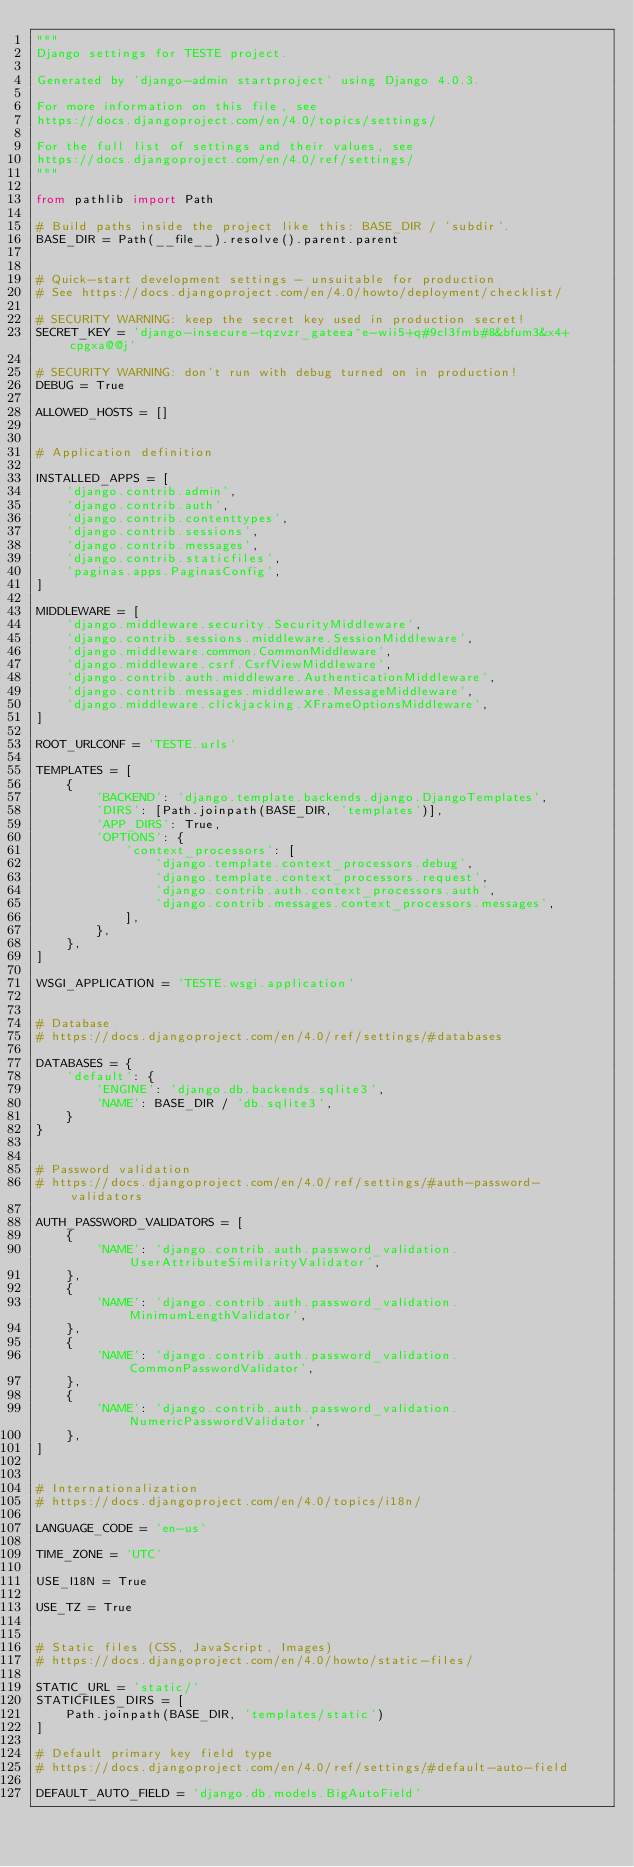Convert code to text. <code><loc_0><loc_0><loc_500><loc_500><_Python_>"""
Django settings for TESTE project.

Generated by 'django-admin startproject' using Django 4.0.3.

For more information on this file, see
https://docs.djangoproject.com/en/4.0/topics/settings/

For the full list of settings and their values, see
https://docs.djangoproject.com/en/4.0/ref/settings/
"""

from pathlib import Path

# Build paths inside the project like this: BASE_DIR / 'subdir'.
BASE_DIR = Path(__file__).resolve().parent.parent


# Quick-start development settings - unsuitable for production
# See https://docs.djangoproject.com/en/4.0/howto/deployment/checklist/

# SECURITY WARNING: keep the secret key used in production secret!
SECRET_KEY = 'django-insecure-tqzvzr_gateea^e-wii5+q#9cl3fmb#8&bfum3&x4+cpgxa@@j'

# SECURITY WARNING: don't run with debug turned on in production!
DEBUG = True

ALLOWED_HOSTS = []


# Application definition

INSTALLED_APPS = [
    'django.contrib.admin',
    'django.contrib.auth',
    'django.contrib.contenttypes',
    'django.contrib.sessions',
    'django.contrib.messages',
    'django.contrib.staticfiles',
    'paginas.apps.PaginasConfig',
]

MIDDLEWARE = [
    'django.middleware.security.SecurityMiddleware',
    'django.contrib.sessions.middleware.SessionMiddleware',
    'django.middleware.common.CommonMiddleware',
    'django.middleware.csrf.CsrfViewMiddleware',
    'django.contrib.auth.middleware.AuthenticationMiddleware',
    'django.contrib.messages.middleware.MessageMiddleware',
    'django.middleware.clickjacking.XFrameOptionsMiddleware',
]

ROOT_URLCONF = 'TESTE.urls'

TEMPLATES = [
    {
        'BACKEND': 'django.template.backends.django.DjangoTemplates',
        'DIRS': [Path.joinpath(BASE_DIR, 'templates')],
        'APP_DIRS': True,
        'OPTIONS': {
            'context_processors': [
                'django.template.context_processors.debug',
                'django.template.context_processors.request',
                'django.contrib.auth.context_processors.auth',
                'django.contrib.messages.context_processors.messages',
            ],
        },
    },
]

WSGI_APPLICATION = 'TESTE.wsgi.application'


# Database
# https://docs.djangoproject.com/en/4.0/ref/settings/#databases

DATABASES = {
    'default': {
        'ENGINE': 'django.db.backends.sqlite3',
        'NAME': BASE_DIR / 'db.sqlite3',
    }
}


# Password validation
# https://docs.djangoproject.com/en/4.0/ref/settings/#auth-password-validators

AUTH_PASSWORD_VALIDATORS = [
    {
        'NAME': 'django.contrib.auth.password_validation.UserAttributeSimilarityValidator',
    },
    {
        'NAME': 'django.contrib.auth.password_validation.MinimumLengthValidator',
    },
    {
        'NAME': 'django.contrib.auth.password_validation.CommonPasswordValidator',
    },
    {
        'NAME': 'django.contrib.auth.password_validation.NumericPasswordValidator',
    },
]


# Internationalization
# https://docs.djangoproject.com/en/4.0/topics/i18n/

LANGUAGE_CODE = 'en-us'

TIME_ZONE = 'UTC'

USE_I18N = True

USE_TZ = True


# Static files (CSS, JavaScript, Images)
# https://docs.djangoproject.com/en/4.0/howto/static-files/

STATIC_URL = 'static/'
STATICFILES_DIRS = [
    Path.joinpath(BASE_DIR, 'templates/static')
]

# Default primary key field type
# https://docs.djangoproject.com/en/4.0/ref/settings/#default-auto-field

DEFAULT_AUTO_FIELD = 'django.db.models.BigAutoField'
</code> 